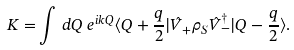Convert formula to latex. <formula><loc_0><loc_0><loc_500><loc_500>K = & \int \, d Q \ e ^ { i k Q } \langle Q + \frac { q } { 2 } | \hat { V } _ { + } \rho _ { S } \hat { V } _ { - } ^ { \dagger } | Q - \frac { q } { 2 } \rangle .</formula> 